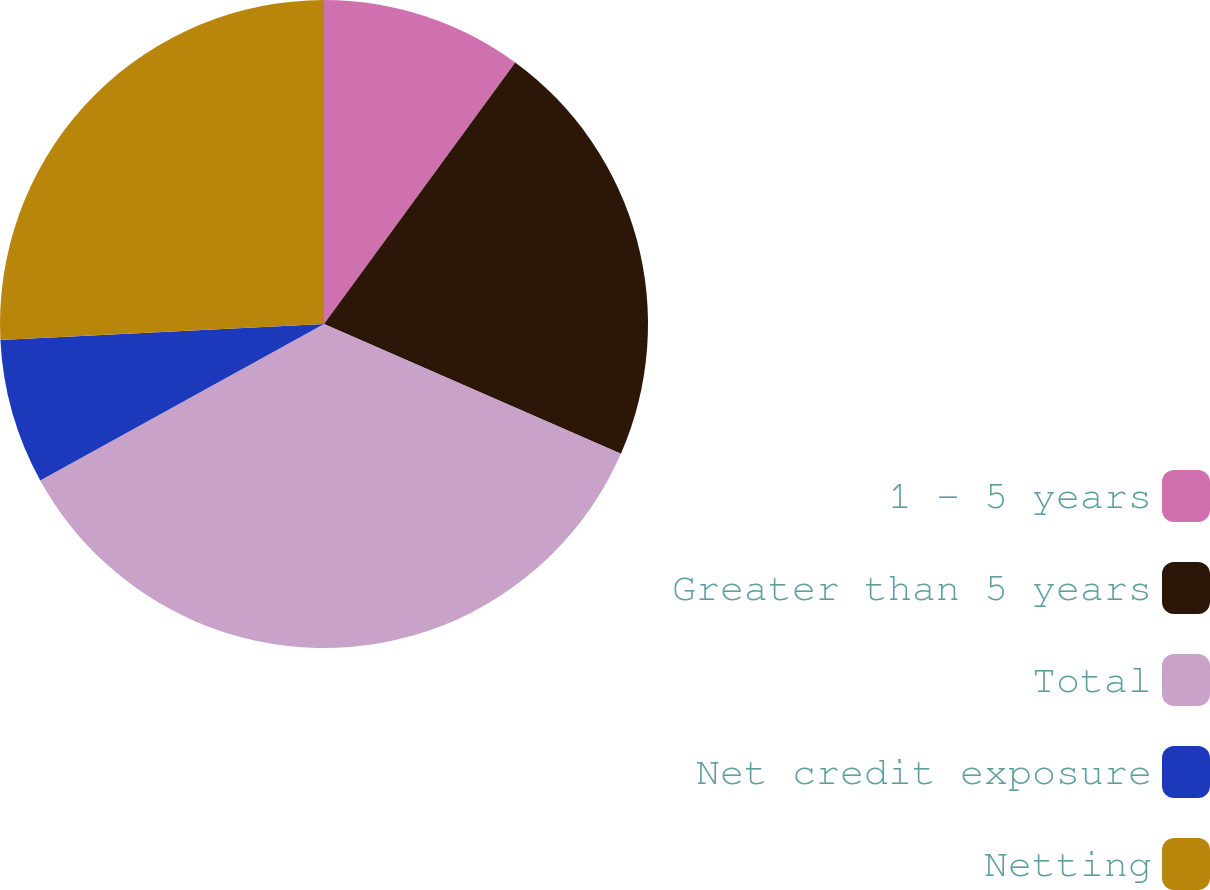Convert chart to OTSL. <chart><loc_0><loc_0><loc_500><loc_500><pie_chart><fcel>1 - 5 years<fcel>Greater than 5 years<fcel>Total<fcel>Net credit exposure<fcel>Netting<nl><fcel>10.05%<fcel>21.51%<fcel>35.43%<fcel>7.23%<fcel>25.79%<nl></chart> 